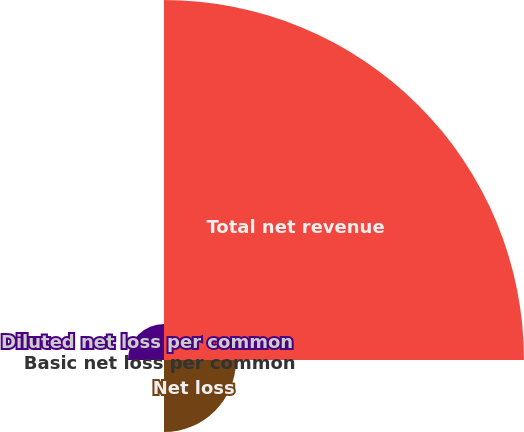Convert chart. <chart><loc_0><loc_0><loc_500><loc_500><pie_chart><fcel>Total net revenue<fcel>Net loss<fcel>Basic net loss per common<fcel>Diluted net loss per common<nl><fcel>76.89%<fcel>15.39%<fcel>0.01%<fcel>7.7%<nl></chart> 